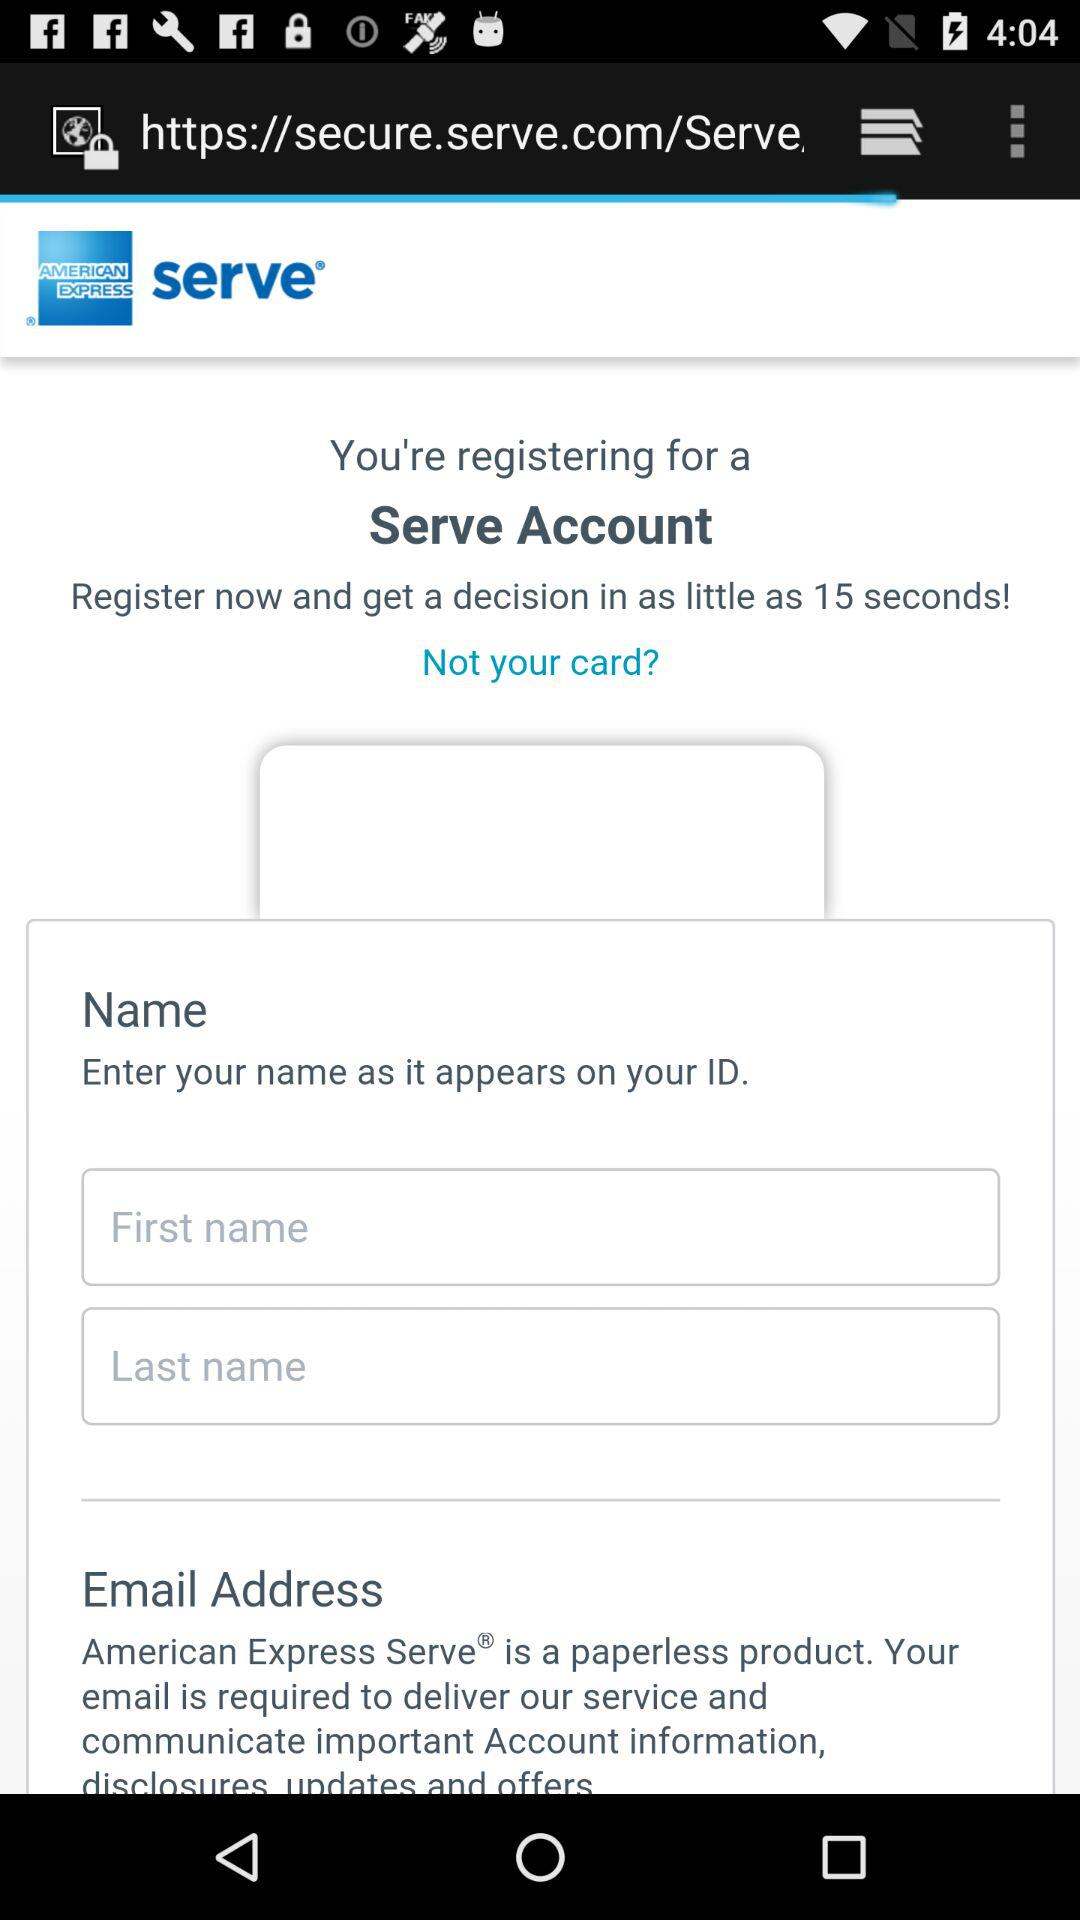What is the application name? The application name is "AMERICAN EXPRESS serve". 